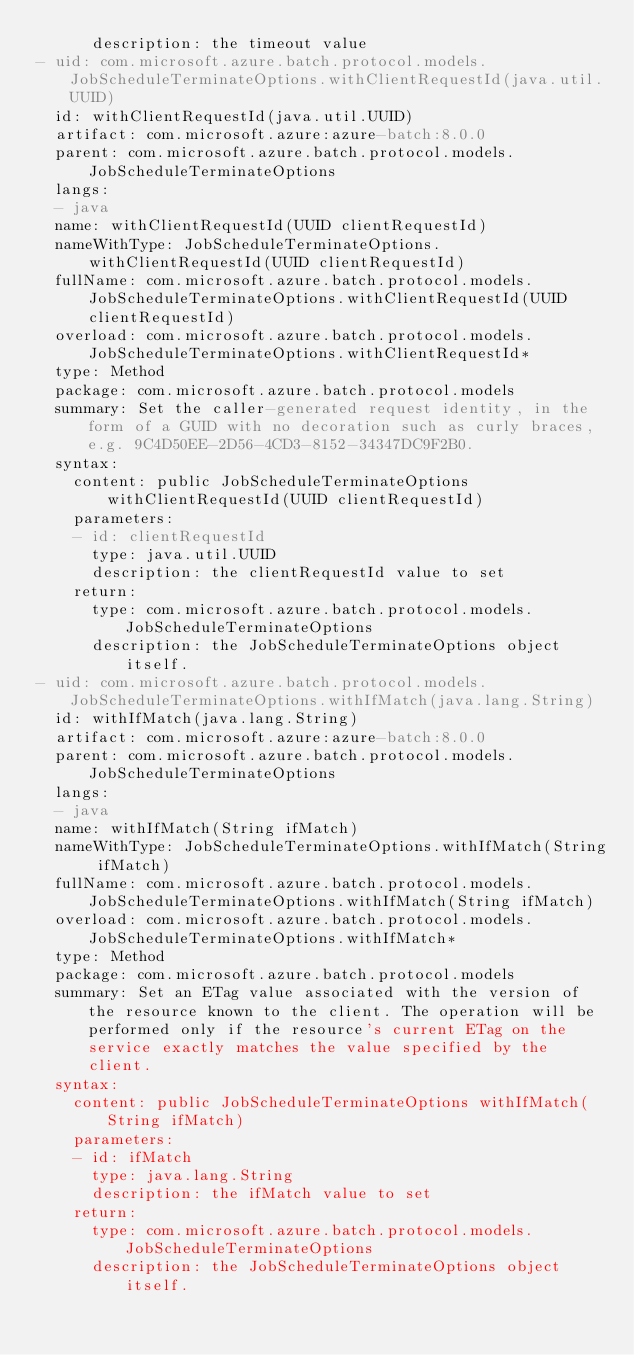Convert code to text. <code><loc_0><loc_0><loc_500><loc_500><_YAML_>      description: the timeout value
- uid: com.microsoft.azure.batch.protocol.models.JobScheduleTerminateOptions.withClientRequestId(java.util.UUID)
  id: withClientRequestId(java.util.UUID)
  artifact: com.microsoft.azure:azure-batch:8.0.0
  parent: com.microsoft.azure.batch.protocol.models.JobScheduleTerminateOptions
  langs:
  - java
  name: withClientRequestId(UUID clientRequestId)
  nameWithType: JobScheduleTerminateOptions.withClientRequestId(UUID clientRequestId)
  fullName: com.microsoft.azure.batch.protocol.models.JobScheduleTerminateOptions.withClientRequestId(UUID clientRequestId)
  overload: com.microsoft.azure.batch.protocol.models.JobScheduleTerminateOptions.withClientRequestId*
  type: Method
  package: com.microsoft.azure.batch.protocol.models
  summary: Set the caller-generated request identity, in the form of a GUID with no decoration such as curly braces, e.g. 9C4D50EE-2D56-4CD3-8152-34347DC9F2B0.
  syntax:
    content: public JobScheduleTerminateOptions withClientRequestId(UUID clientRequestId)
    parameters:
    - id: clientRequestId
      type: java.util.UUID
      description: the clientRequestId value to set
    return:
      type: com.microsoft.azure.batch.protocol.models.JobScheduleTerminateOptions
      description: the JobScheduleTerminateOptions object itself.
- uid: com.microsoft.azure.batch.protocol.models.JobScheduleTerminateOptions.withIfMatch(java.lang.String)
  id: withIfMatch(java.lang.String)
  artifact: com.microsoft.azure:azure-batch:8.0.0
  parent: com.microsoft.azure.batch.protocol.models.JobScheduleTerminateOptions
  langs:
  - java
  name: withIfMatch(String ifMatch)
  nameWithType: JobScheduleTerminateOptions.withIfMatch(String ifMatch)
  fullName: com.microsoft.azure.batch.protocol.models.JobScheduleTerminateOptions.withIfMatch(String ifMatch)
  overload: com.microsoft.azure.batch.protocol.models.JobScheduleTerminateOptions.withIfMatch*
  type: Method
  package: com.microsoft.azure.batch.protocol.models
  summary: Set an ETag value associated with the version of the resource known to the client. The operation will be performed only if the resource's current ETag on the service exactly matches the value specified by the client.
  syntax:
    content: public JobScheduleTerminateOptions withIfMatch(String ifMatch)
    parameters:
    - id: ifMatch
      type: java.lang.String
      description: the ifMatch value to set
    return:
      type: com.microsoft.azure.batch.protocol.models.JobScheduleTerminateOptions
      description: the JobScheduleTerminateOptions object itself.</code> 